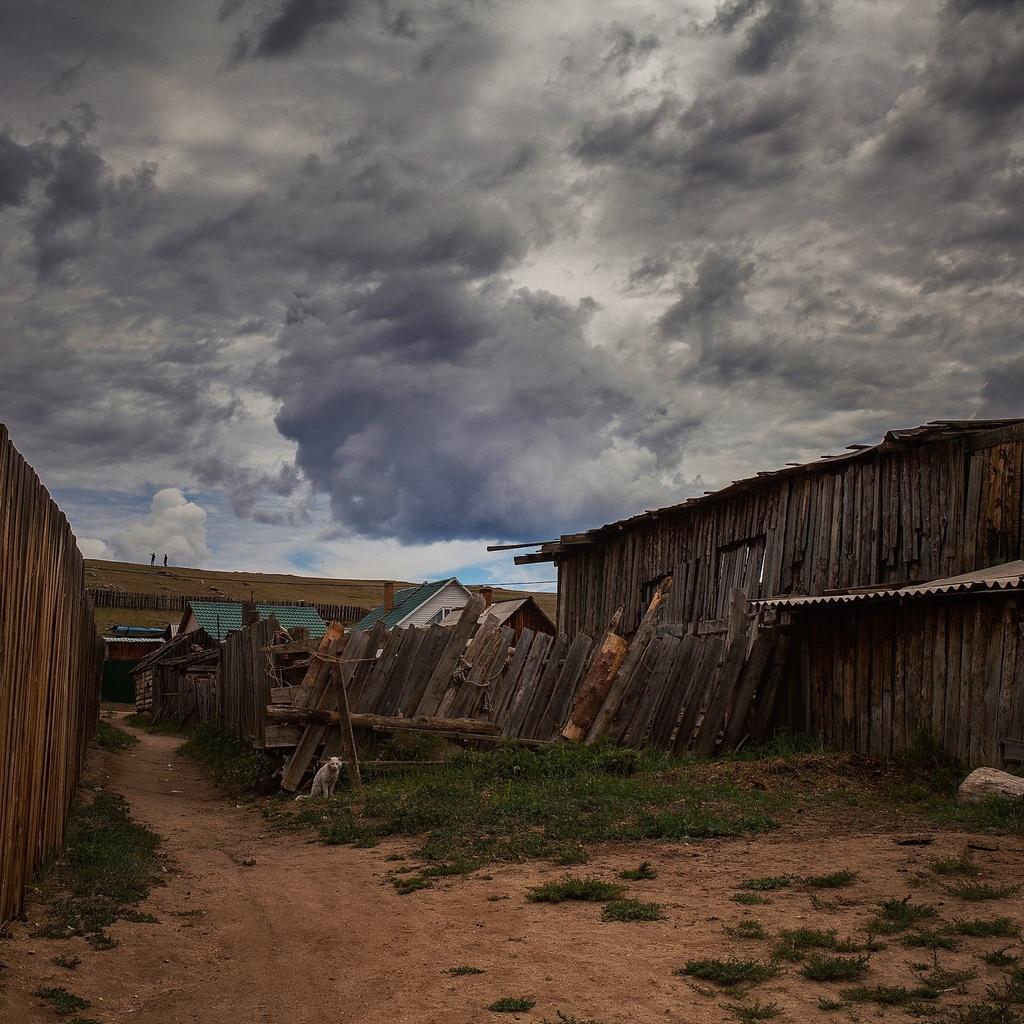How would you summarize this image in a sentence or two? In this picture we can see an animal on the path. Behind the animal there are some wooden objects, houses, wooden fence and the sky. 